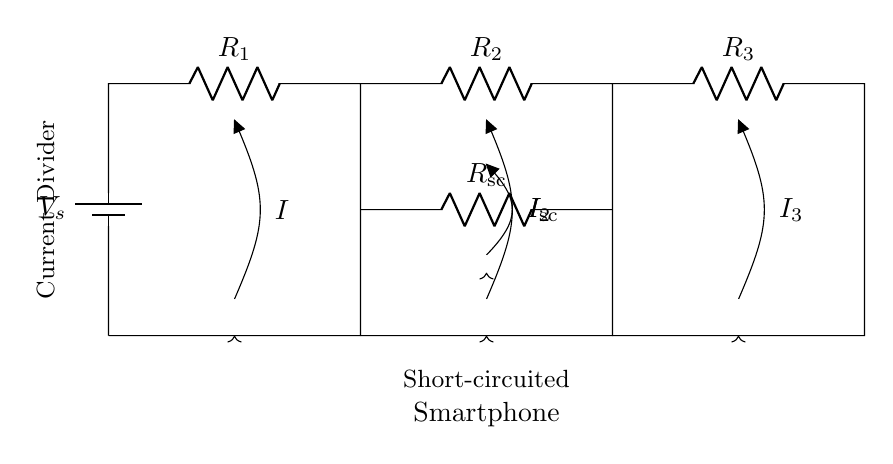What is the total voltage supplied in the circuit? The total voltage supplied is denoted by \(V_s\) in the circuit diagram. Since it is a battery connected at the start, this is the initial voltage before any resistive division occurs.
Answer: \(V_s\) How many resistors are present in this circuit? There are three resistors denoted as \(R_1\), \(R_2\), and \(R_3\) in the circuit diagram, in addition to a short-circuit resistor \(R_{\text{sc}}\). Counting these gives a total of four resistors.
Answer: 4 What is the relationship between the branch currents \(I\), \(I_2\), and \(I_3\)? In a current divider, the total current \(I\) splits among the different branches. The relationship follows the inverse of the resistances, meaning \(I = I_2 + I_3 + I_{\text{sc}}\), where each branch experiences a different portion of the total current based on its resistance.
Answer: \(I\) What would happen to the branch currents if \(R_2 = R_3\)? If \(R_2\) equals \(R_3\), the current would equally divide between these two branches, leading to \(I_2 = I_3\). The current division formula indicates that with identical resistances, the current is evenly distributed.
Answer: Equal currents What is the purpose of the short-circuit resistor \(R_{\text{sc}}\) in this circuit? The short-circuit resistor serves to model the scenario of a fault in the smartphone, simulating conditions that would lead to increased current flow through the branches, affecting how \(I\) is distributed across \(I_2\), \(I_3\), and \(I_{\text{sc}}\). This helps analyze how the device would behave under faulty conditions.
Answer: Fault simulation If the resistance \(R_1\) is much smaller than \(R_2\) and \(R_3\), how will that affect the current division? If \(R_1\) is much smaller, most of the current will flow through \(R_1\), resulting in a very small \(I_2\) and \(I_3\). The current divides in inverse proportion to resistance, so smaller resistances will draw more current. This means the current distribution will heavily favor \(R_1\).
Answer: More current through \(R_1\) 